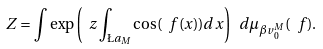<formula> <loc_0><loc_0><loc_500><loc_500>Z = \int \exp \left ( \ z \int _ { \L a _ { M } } \cos ( \ f ( x ) ) d x \right ) \ d \mu _ { \beta v ^ { M } _ { 0 } } ( \ f ) .</formula> 